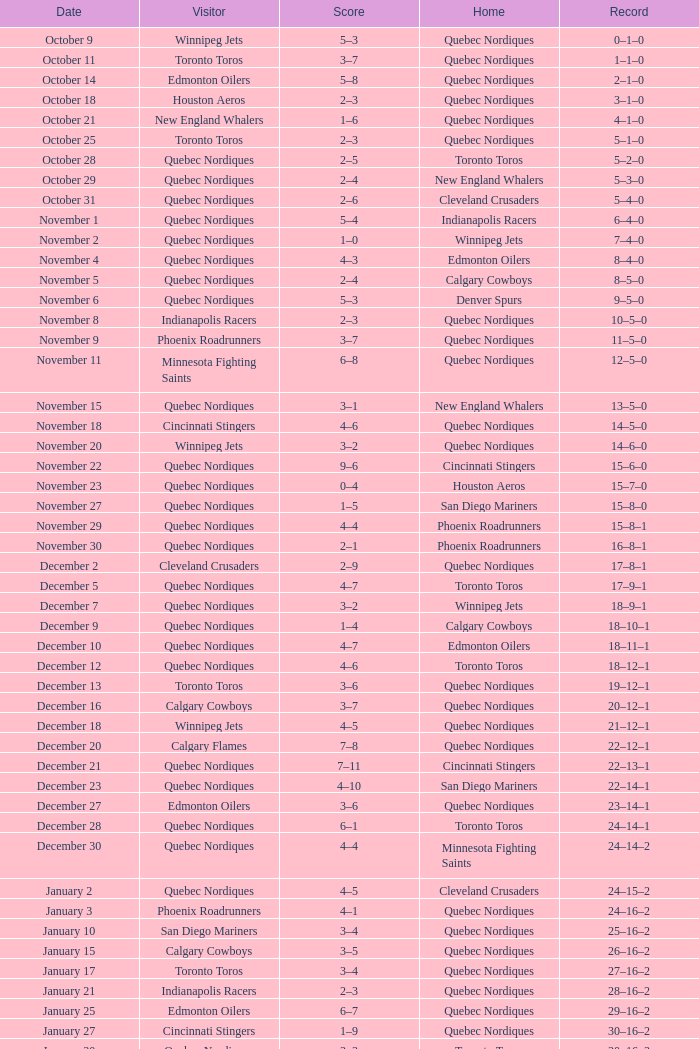What was the date of the match with a score of 2–1? November 30. 